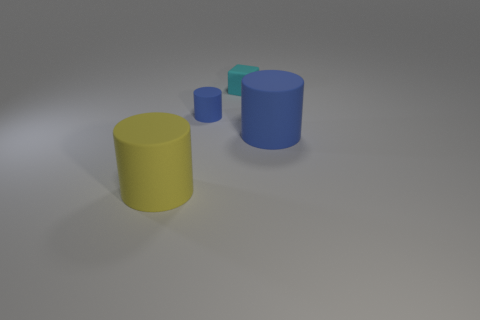Are there any cyan rubber cylinders that have the same size as the yellow matte cylinder?
Provide a short and direct response. No. What material is the blue thing that is the same size as the rubber block?
Offer a very short reply. Rubber. What size is the cyan object that is to the right of the cylinder left of the tiny blue rubber thing?
Provide a short and direct response. Small. There is a blue rubber cylinder to the left of the matte cube; is its size the same as the large yellow matte cylinder?
Offer a terse response. No. Is the number of yellow rubber cylinders to the right of the tiny cyan object greater than the number of rubber cylinders behind the large yellow object?
Your answer should be compact. No. There is a thing that is on the left side of the small cyan block and behind the big blue rubber cylinder; what shape is it?
Offer a very short reply. Cylinder. There is a large thing that is behind the yellow thing; what is its shape?
Offer a terse response. Cylinder. There is a cylinder in front of the large matte cylinder that is behind the big object to the left of the big blue object; how big is it?
Give a very brief answer. Large. Is the shape of the small blue rubber object the same as the large yellow object?
Your response must be concise. Yes. There is a matte cylinder that is both in front of the tiny blue object and on the left side of the cyan block; what size is it?
Provide a succinct answer. Large. 